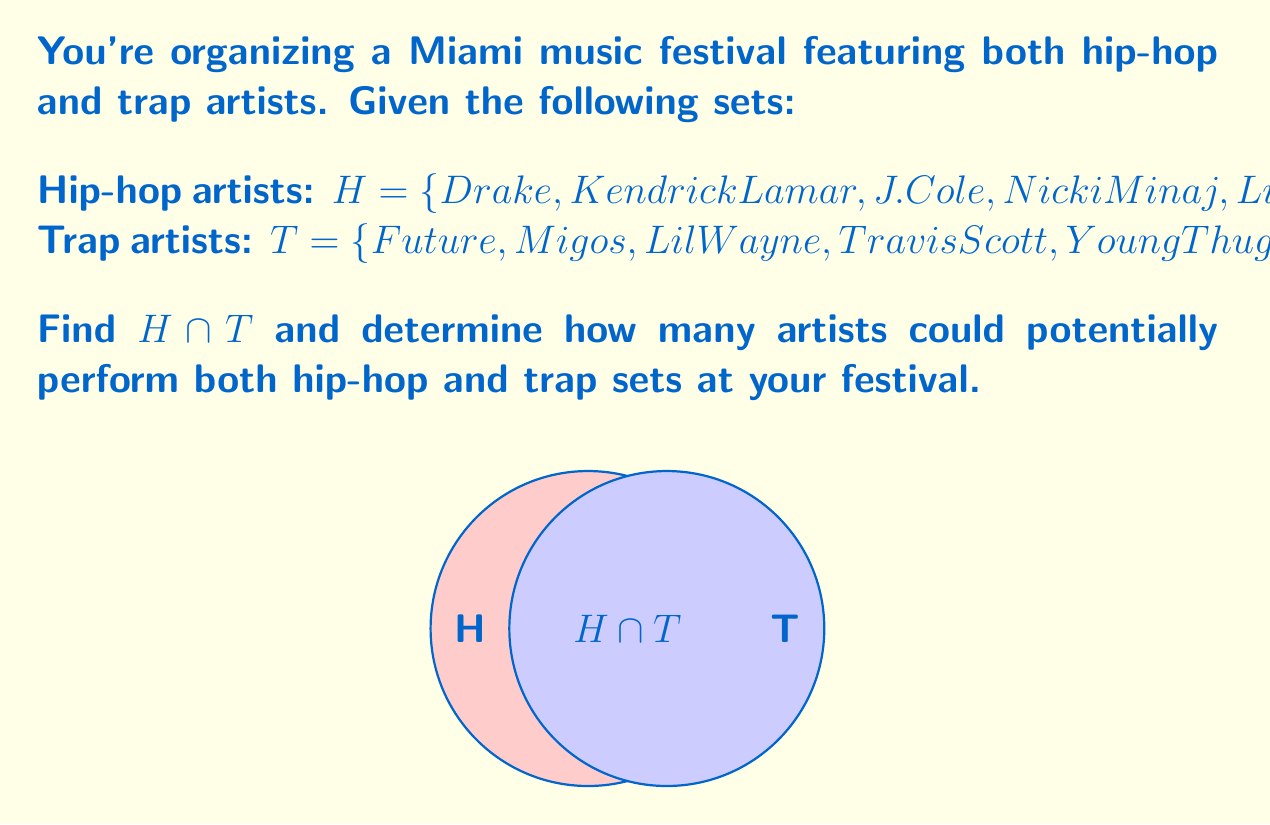Help me with this question. To solve this problem, we need to find the intersection of sets $H$ and $T$. The intersection $H \cap T$ contains all elements that are present in both sets.

Step 1: Identify common elements in both sets.
- Comparing the elements of $H$ and $T$, we see that Lil Wayne appears in both sets.

Step 2: Write the intersection set.
$H \cap T = \{Lil Wayne\}$

Step 3: Count the number of elements in the intersection.
The set $H \cap T$ contains only one element.

Therefore, there is one artist who could potentially perform both hip-hop and trap sets at your Miami music festival.
Answer: $H \cap T = \{Lil Wayne\}$; 1 artist 